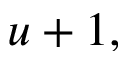<formula> <loc_0><loc_0><loc_500><loc_500>u + 1 ,</formula> 